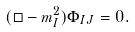<formula> <loc_0><loc_0><loc_500><loc_500>( \Box - m _ { I } ^ { 2 } ) \Phi _ { I J } = 0 .</formula> 